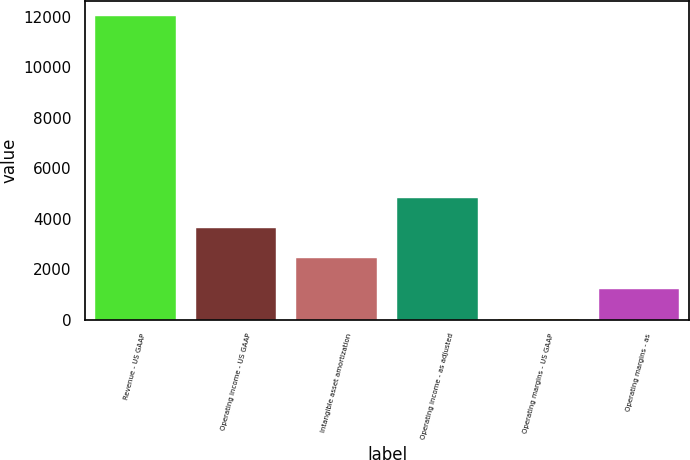Convert chart. <chart><loc_0><loc_0><loc_500><loc_500><bar_chart><fcel>Revenue - US GAAP<fcel>Operating income - US GAAP<fcel>Intangible asset amortization<fcel>Operating income - as adjusted<fcel>Operating margins - US GAAP<fcel>Operating margins - as<nl><fcel>12045<fcel>3624.91<fcel>2422.04<fcel>4827.78<fcel>16.3<fcel>1219.17<nl></chart> 